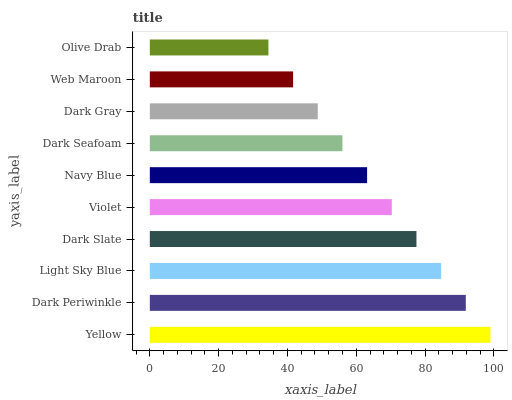Is Olive Drab the minimum?
Answer yes or no. Yes. Is Yellow the maximum?
Answer yes or no. Yes. Is Dark Periwinkle the minimum?
Answer yes or no. No. Is Dark Periwinkle the maximum?
Answer yes or no. No. Is Yellow greater than Dark Periwinkle?
Answer yes or no. Yes. Is Dark Periwinkle less than Yellow?
Answer yes or no. Yes. Is Dark Periwinkle greater than Yellow?
Answer yes or no. No. Is Yellow less than Dark Periwinkle?
Answer yes or no. No. Is Violet the high median?
Answer yes or no. Yes. Is Navy Blue the low median?
Answer yes or no. Yes. Is Dark Slate the high median?
Answer yes or no. No. Is Dark Seafoam the low median?
Answer yes or no. No. 